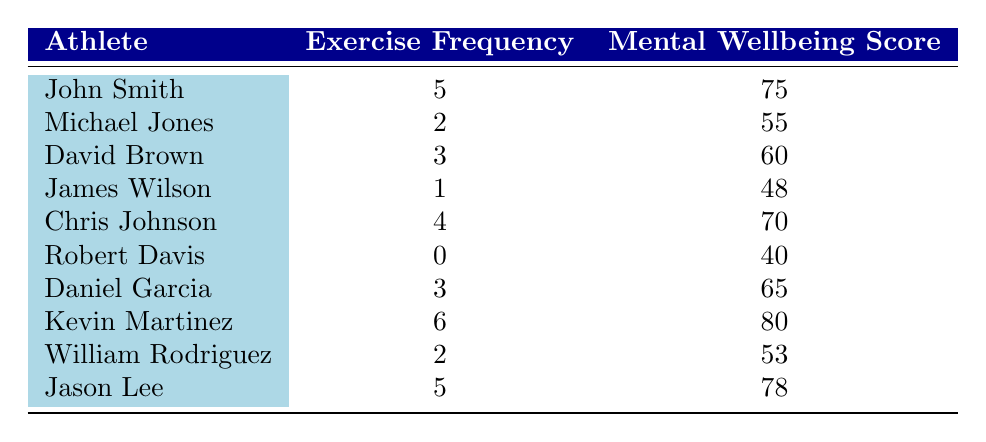What is the mental wellbeing score of Kevin Martinez? The table indicates that Kevin Martinez has a mental wellbeing score of 80.
Answer: 80 What is the exercise frequency of Robert Davis? According to the table, Robert Davis exercises 0 times per week.
Answer: 0 Which athlete has the highest mental wellbeing score? By scanning the mental wellbeing scores, Kevin Martinez has the highest score of 80.
Answer: Kevin Martinez What is the average exercise frequency of all the athletes? To calculate the average, sum the exercise frequencies (5 + 2 + 3 + 1 + 4 + 0 + 3 + 6 + 2 + 5) = 31, and then divide by the number of athletes (10). Thus, the average is 31/10 = 3.1.
Answer: 3.1 Is there an athlete who does not exercise at all? Yes, Robert Davis has an exercise frequency of 0.
Answer: Yes What is the difference in mental wellbeing scores between the highest and lowest scores? The highest score is 80 from Kevin Martinez and the lowest score is 40 from Robert Davis. So, the difference is 80 - 40 = 40.
Answer: 40 How many athletes exercise 5 times per week? The table shows that there are two athletes, John Smith and Jason Lee, who both exercise 5 times a week.
Answer: 2 If an athlete increases their exercise frequency from 2 to 4 times a week, how much would we expect their mental wellbeing score to change based on the data? Michael Jones, who exercises 2 times a week, has a mental wellbeing score of 55, and Chris Johnson, who exercises 4 times weekly, has a score of 70. Therefore, the expected change in their score is 70 - 55 = 15.
Answer: 15 Which exercise frequency corresponds to the average mental wellbeing score? To find this, we calculate the average mental wellbeing score. The total score is (75 + 55 + 60 + 48 + 70 + 40 + 65 + 80 + 53 + 78) = 724. Dividing by the total number of athletes (10), we get an average score of 72.4, falling between the scores of Chris Johnson and David Brown (both at 60 and 70, respectively) for an exercise frequency of 4.
Answer: 4 